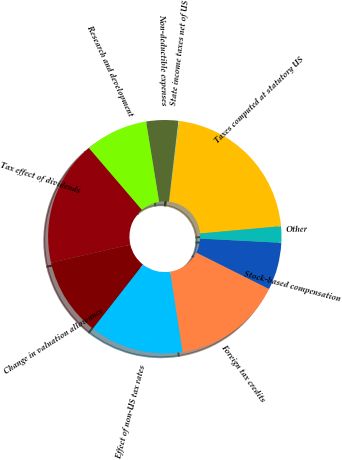Convert chart. <chart><loc_0><loc_0><loc_500><loc_500><pie_chart><fcel>Taxes computed at statutory US<fcel>State income taxes net of US<fcel>Non-deductible expenses<fcel>Research and development<fcel>Tax effect of dividends<fcel>Change in valuation allowance<fcel>Effect of non-US tax rates<fcel>Foreign tax credits<fcel>Stock-based compensation<fcel>Other<nl><fcel>21.61%<fcel>0.11%<fcel>4.41%<fcel>8.71%<fcel>17.31%<fcel>10.86%<fcel>13.01%<fcel>15.16%<fcel>6.56%<fcel>2.26%<nl></chart> 